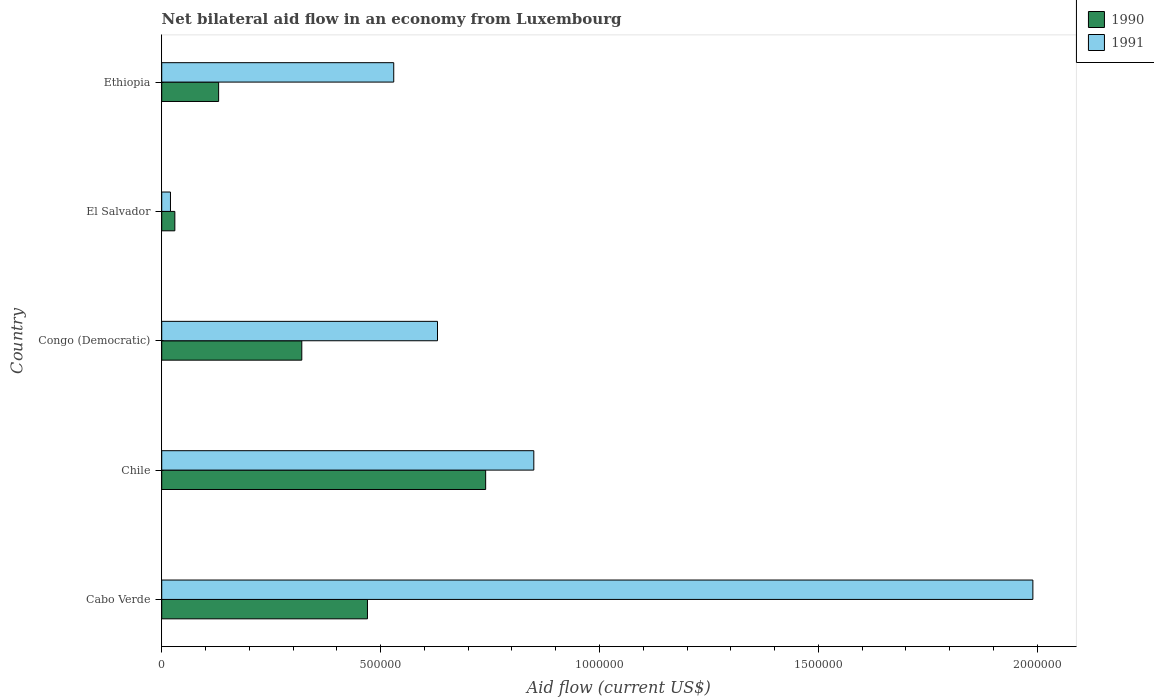How many groups of bars are there?
Offer a terse response. 5. Are the number of bars per tick equal to the number of legend labels?
Give a very brief answer. Yes. Are the number of bars on each tick of the Y-axis equal?
Provide a short and direct response. Yes. How many bars are there on the 1st tick from the bottom?
Keep it short and to the point. 2. What is the label of the 1st group of bars from the top?
Provide a succinct answer. Ethiopia. In how many cases, is the number of bars for a given country not equal to the number of legend labels?
Your answer should be compact. 0. What is the net bilateral aid flow in 1990 in Congo (Democratic)?
Keep it short and to the point. 3.20e+05. Across all countries, what is the maximum net bilateral aid flow in 1990?
Provide a short and direct response. 7.40e+05. In which country was the net bilateral aid flow in 1991 maximum?
Your answer should be very brief. Cabo Verde. In which country was the net bilateral aid flow in 1991 minimum?
Your answer should be compact. El Salvador. What is the total net bilateral aid flow in 1990 in the graph?
Provide a short and direct response. 1.69e+06. What is the difference between the net bilateral aid flow in 1990 in El Salvador and the net bilateral aid flow in 1991 in Congo (Democratic)?
Your answer should be compact. -6.00e+05. What is the average net bilateral aid flow in 1991 per country?
Offer a very short reply. 8.04e+05. What is the difference between the net bilateral aid flow in 1990 and net bilateral aid flow in 1991 in Cabo Verde?
Your answer should be compact. -1.52e+06. In how many countries, is the net bilateral aid flow in 1991 greater than 600000 US$?
Your response must be concise. 3. What is the ratio of the net bilateral aid flow in 1991 in Chile to that in Ethiopia?
Your answer should be compact. 1.6. Is the net bilateral aid flow in 1991 in Cabo Verde less than that in Chile?
Make the answer very short. No. Is the difference between the net bilateral aid flow in 1990 in Chile and El Salvador greater than the difference between the net bilateral aid flow in 1991 in Chile and El Salvador?
Give a very brief answer. No. What is the difference between the highest and the second highest net bilateral aid flow in 1991?
Provide a succinct answer. 1.14e+06. What is the difference between the highest and the lowest net bilateral aid flow in 1991?
Your answer should be compact. 1.97e+06. Is the sum of the net bilateral aid flow in 1990 in Cabo Verde and Ethiopia greater than the maximum net bilateral aid flow in 1991 across all countries?
Provide a succinct answer. No. What does the 1st bar from the top in Congo (Democratic) represents?
Provide a short and direct response. 1991. How many countries are there in the graph?
Offer a very short reply. 5. Does the graph contain grids?
Offer a terse response. No. Where does the legend appear in the graph?
Provide a succinct answer. Top right. What is the title of the graph?
Ensure brevity in your answer.  Net bilateral aid flow in an economy from Luxembourg. Does "1970" appear as one of the legend labels in the graph?
Provide a succinct answer. No. What is the Aid flow (current US$) of 1991 in Cabo Verde?
Keep it short and to the point. 1.99e+06. What is the Aid flow (current US$) of 1990 in Chile?
Your answer should be very brief. 7.40e+05. What is the Aid flow (current US$) of 1991 in Chile?
Your answer should be very brief. 8.50e+05. What is the Aid flow (current US$) in 1990 in Congo (Democratic)?
Your answer should be compact. 3.20e+05. What is the Aid flow (current US$) in 1991 in Congo (Democratic)?
Your answer should be very brief. 6.30e+05. What is the Aid flow (current US$) of 1991 in El Salvador?
Provide a short and direct response. 2.00e+04. What is the Aid flow (current US$) of 1991 in Ethiopia?
Offer a terse response. 5.30e+05. Across all countries, what is the maximum Aid flow (current US$) in 1990?
Provide a succinct answer. 7.40e+05. Across all countries, what is the maximum Aid flow (current US$) in 1991?
Give a very brief answer. 1.99e+06. Across all countries, what is the minimum Aid flow (current US$) of 1991?
Keep it short and to the point. 2.00e+04. What is the total Aid flow (current US$) of 1990 in the graph?
Give a very brief answer. 1.69e+06. What is the total Aid flow (current US$) of 1991 in the graph?
Ensure brevity in your answer.  4.02e+06. What is the difference between the Aid flow (current US$) of 1991 in Cabo Verde and that in Chile?
Your answer should be very brief. 1.14e+06. What is the difference between the Aid flow (current US$) of 1990 in Cabo Verde and that in Congo (Democratic)?
Provide a succinct answer. 1.50e+05. What is the difference between the Aid flow (current US$) in 1991 in Cabo Verde and that in Congo (Democratic)?
Offer a very short reply. 1.36e+06. What is the difference between the Aid flow (current US$) of 1991 in Cabo Verde and that in El Salvador?
Your answer should be very brief. 1.97e+06. What is the difference between the Aid flow (current US$) in 1990 in Cabo Verde and that in Ethiopia?
Provide a short and direct response. 3.40e+05. What is the difference between the Aid flow (current US$) of 1991 in Cabo Verde and that in Ethiopia?
Offer a very short reply. 1.46e+06. What is the difference between the Aid flow (current US$) of 1991 in Chile and that in Congo (Democratic)?
Give a very brief answer. 2.20e+05. What is the difference between the Aid flow (current US$) in 1990 in Chile and that in El Salvador?
Your response must be concise. 7.10e+05. What is the difference between the Aid flow (current US$) of 1991 in Chile and that in El Salvador?
Offer a very short reply. 8.30e+05. What is the difference between the Aid flow (current US$) in 1990 in Congo (Democratic) and that in El Salvador?
Provide a succinct answer. 2.90e+05. What is the difference between the Aid flow (current US$) of 1991 in Congo (Democratic) and that in El Salvador?
Provide a short and direct response. 6.10e+05. What is the difference between the Aid flow (current US$) in 1991 in Congo (Democratic) and that in Ethiopia?
Make the answer very short. 1.00e+05. What is the difference between the Aid flow (current US$) of 1990 in El Salvador and that in Ethiopia?
Offer a very short reply. -1.00e+05. What is the difference between the Aid flow (current US$) of 1991 in El Salvador and that in Ethiopia?
Your response must be concise. -5.10e+05. What is the difference between the Aid flow (current US$) in 1990 in Cabo Verde and the Aid flow (current US$) in 1991 in Chile?
Offer a very short reply. -3.80e+05. What is the difference between the Aid flow (current US$) in 1990 in Cabo Verde and the Aid flow (current US$) in 1991 in Congo (Democratic)?
Make the answer very short. -1.60e+05. What is the difference between the Aid flow (current US$) in 1990 in Cabo Verde and the Aid flow (current US$) in 1991 in El Salvador?
Provide a succinct answer. 4.50e+05. What is the difference between the Aid flow (current US$) of 1990 in Cabo Verde and the Aid flow (current US$) of 1991 in Ethiopia?
Offer a very short reply. -6.00e+04. What is the difference between the Aid flow (current US$) in 1990 in Chile and the Aid flow (current US$) in 1991 in Congo (Democratic)?
Your response must be concise. 1.10e+05. What is the difference between the Aid flow (current US$) of 1990 in Chile and the Aid flow (current US$) of 1991 in El Salvador?
Give a very brief answer. 7.20e+05. What is the difference between the Aid flow (current US$) of 1990 in Chile and the Aid flow (current US$) of 1991 in Ethiopia?
Offer a very short reply. 2.10e+05. What is the difference between the Aid flow (current US$) in 1990 in Congo (Democratic) and the Aid flow (current US$) in 1991 in Ethiopia?
Your response must be concise. -2.10e+05. What is the difference between the Aid flow (current US$) in 1990 in El Salvador and the Aid flow (current US$) in 1991 in Ethiopia?
Make the answer very short. -5.00e+05. What is the average Aid flow (current US$) in 1990 per country?
Your response must be concise. 3.38e+05. What is the average Aid flow (current US$) of 1991 per country?
Your response must be concise. 8.04e+05. What is the difference between the Aid flow (current US$) in 1990 and Aid flow (current US$) in 1991 in Cabo Verde?
Provide a succinct answer. -1.52e+06. What is the difference between the Aid flow (current US$) in 1990 and Aid flow (current US$) in 1991 in Congo (Democratic)?
Give a very brief answer. -3.10e+05. What is the difference between the Aid flow (current US$) in 1990 and Aid flow (current US$) in 1991 in Ethiopia?
Your response must be concise. -4.00e+05. What is the ratio of the Aid flow (current US$) in 1990 in Cabo Verde to that in Chile?
Your answer should be compact. 0.64. What is the ratio of the Aid flow (current US$) of 1991 in Cabo Verde to that in Chile?
Give a very brief answer. 2.34. What is the ratio of the Aid flow (current US$) in 1990 in Cabo Verde to that in Congo (Democratic)?
Make the answer very short. 1.47. What is the ratio of the Aid flow (current US$) of 1991 in Cabo Verde to that in Congo (Democratic)?
Provide a short and direct response. 3.16. What is the ratio of the Aid flow (current US$) of 1990 in Cabo Verde to that in El Salvador?
Ensure brevity in your answer.  15.67. What is the ratio of the Aid flow (current US$) in 1991 in Cabo Verde to that in El Salvador?
Provide a succinct answer. 99.5. What is the ratio of the Aid flow (current US$) in 1990 in Cabo Verde to that in Ethiopia?
Your answer should be very brief. 3.62. What is the ratio of the Aid flow (current US$) in 1991 in Cabo Verde to that in Ethiopia?
Offer a terse response. 3.75. What is the ratio of the Aid flow (current US$) in 1990 in Chile to that in Congo (Democratic)?
Provide a short and direct response. 2.31. What is the ratio of the Aid flow (current US$) in 1991 in Chile to that in Congo (Democratic)?
Offer a very short reply. 1.35. What is the ratio of the Aid flow (current US$) of 1990 in Chile to that in El Salvador?
Make the answer very short. 24.67. What is the ratio of the Aid flow (current US$) of 1991 in Chile to that in El Salvador?
Provide a succinct answer. 42.5. What is the ratio of the Aid flow (current US$) of 1990 in Chile to that in Ethiopia?
Your response must be concise. 5.69. What is the ratio of the Aid flow (current US$) of 1991 in Chile to that in Ethiopia?
Offer a terse response. 1.6. What is the ratio of the Aid flow (current US$) of 1990 in Congo (Democratic) to that in El Salvador?
Keep it short and to the point. 10.67. What is the ratio of the Aid flow (current US$) of 1991 in Congo (Democratic) to that in El Salvador?
Provide a succinct answer. 31.5. What is the ratio of the Aid flow (current US$) in 1990 in Congo (Democratic) to that in Ethiopia?
Ensure brevity in your answer.  2.46. What is the ratio of the Aid flow (current US$) of 1991 in Congo (Democratic) to that in Ethiopia?
Your answer should be compact. 1.19. What is the ratio of the Aid flow (current US$) in 1990 in El Salvador to that in Ethiopia?
Provide a succinct answer. 0.23. What is the ratio of the Aid flow (current US$) in 1991 in El Salvador to that in Ethiopia?
Your answer should be very brief. 0.04. What is the difference between the highest and the second highest Aid flow (current US$) in 1991?
Provide a succinct answer. 1.14e+06. What is the difference between the highest and the lowest Aid flow (current US$) of 1990?
Your answer should be compact. 7.10e+05. What is the difference between the highest and the lowest Aid flow (current US$) in 1991?
Your answer should be compact. 1.97e+06. 